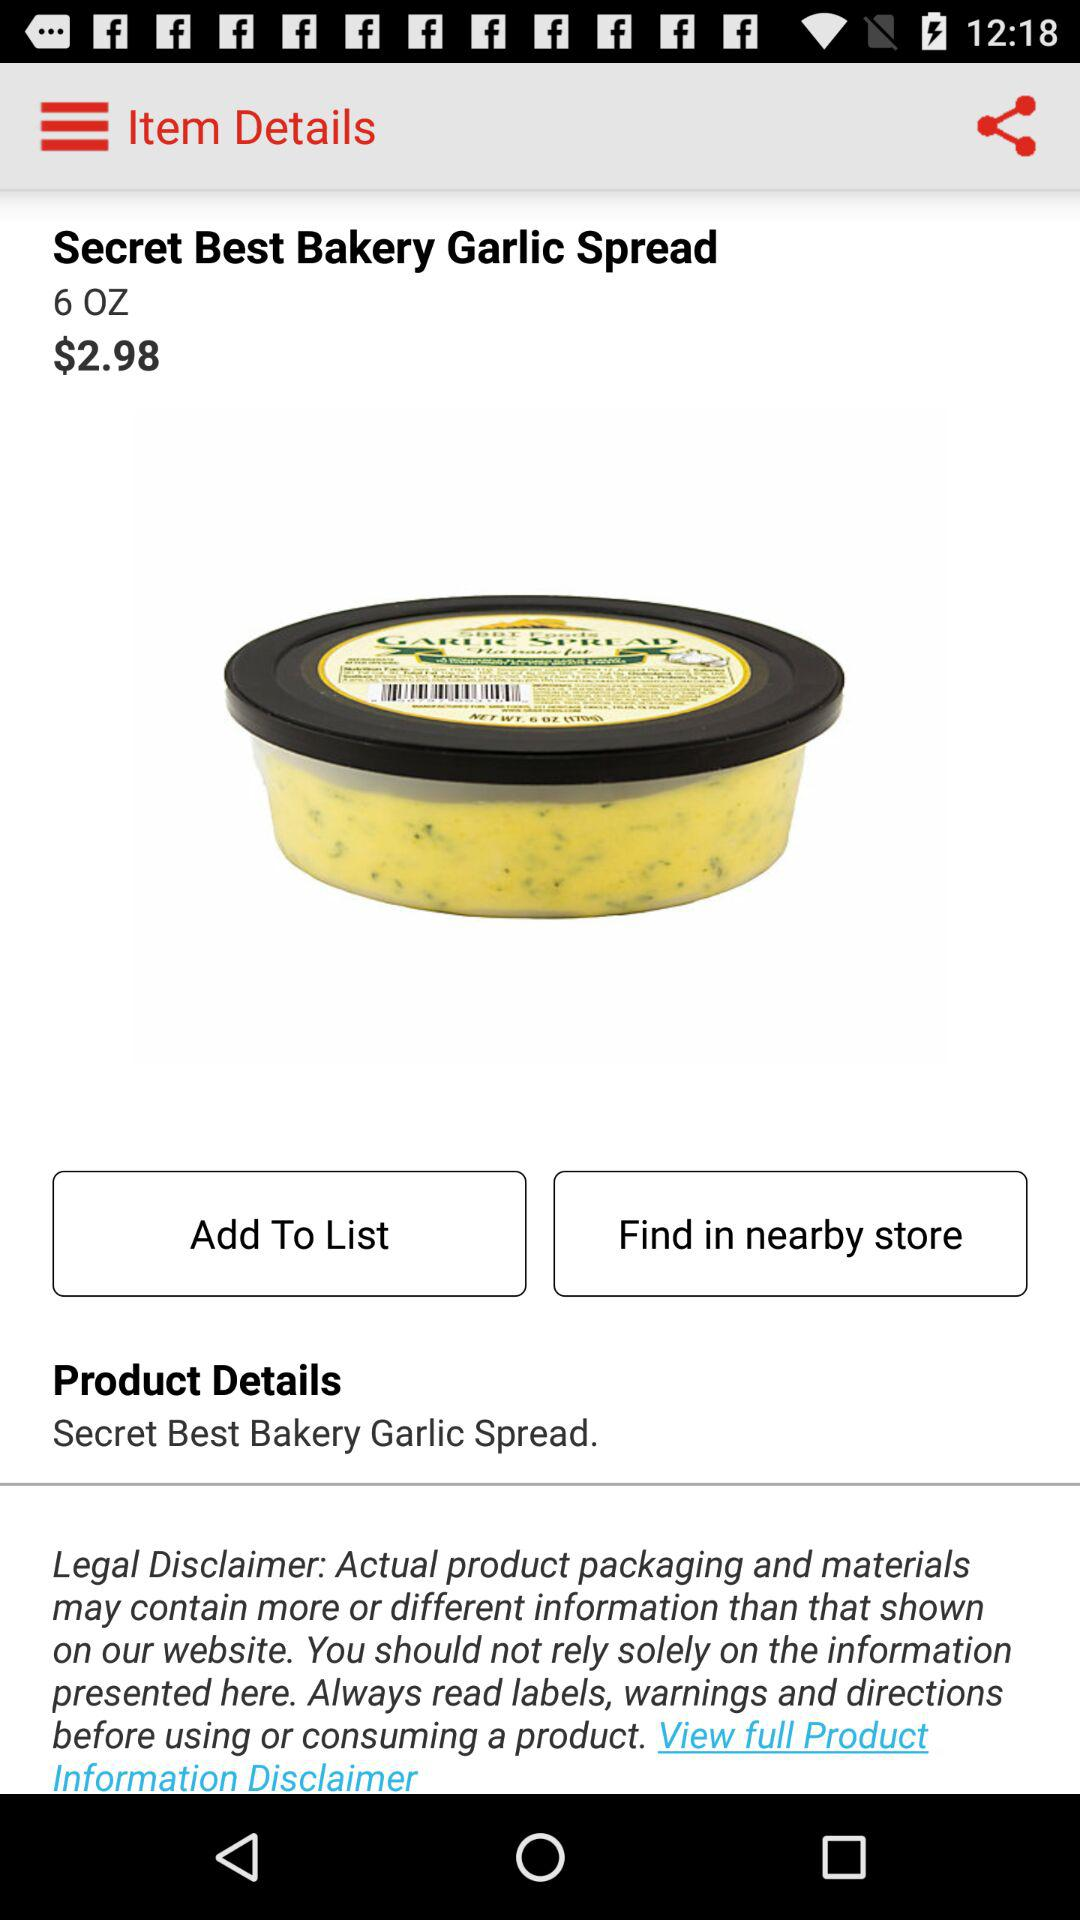What is the price? The price is $2.98. 